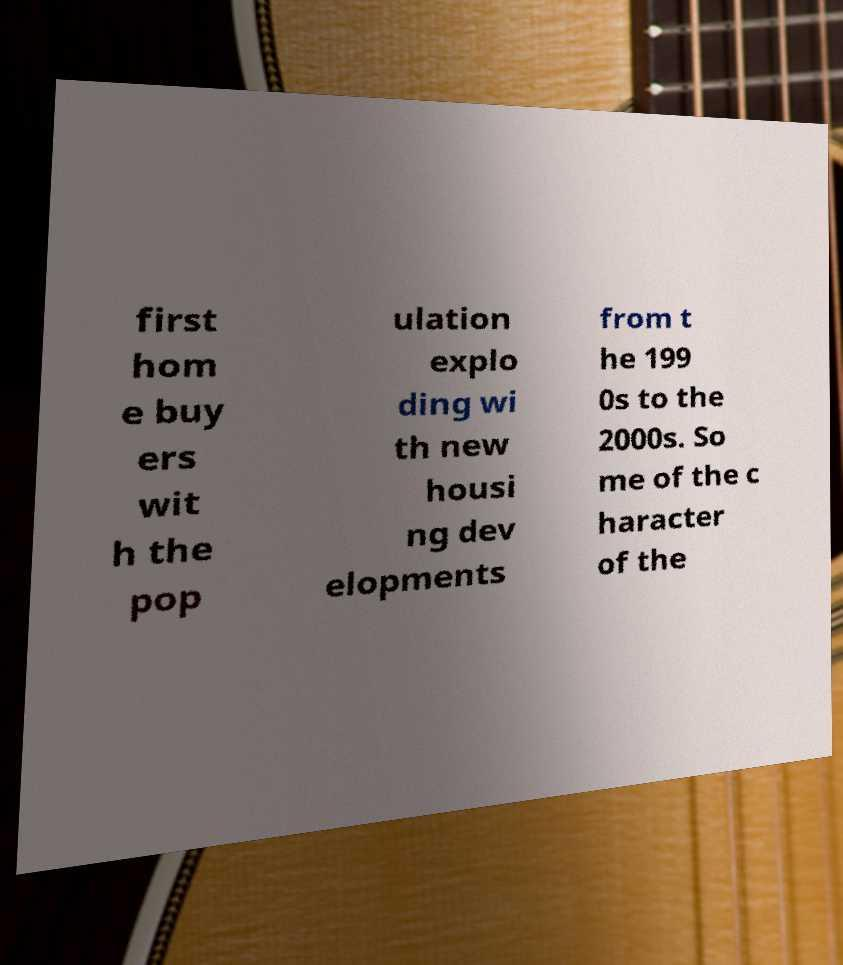What messages or text are displayed in this image? I need them in a readable, typed format. first hom e buy ers wit h the pop ulation explo ding wi th new housi ng dev elopments from t he 199 0s to the 2000s. So me of the c haracter of the 